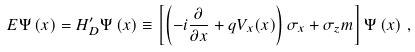Convert formula to latex. <formula><loc_0><loc_0><loc_500><loc_500>E \Psi \left ( x \right ) = H _ { D } ^ { \prime } \Psi \left ( x \right ) \equiv \left [ \left ( - i \frac { \partial } { \partial x } + q V _ { x } ( x ) \right ) \sigma _ { x } + \sigma _ { z } m \right ] \Psi \left ( x \right ) \, ,</formula> 